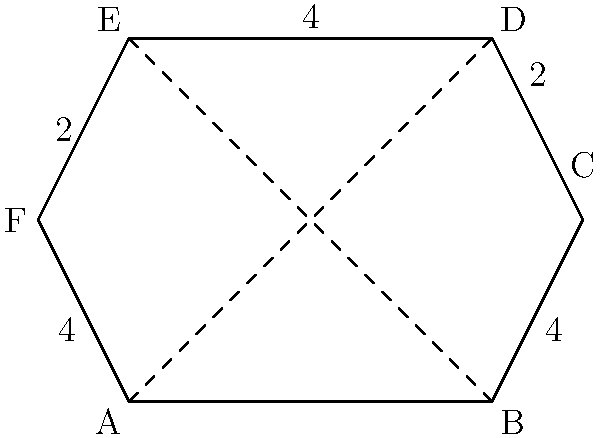In a study on the visual representation of medication in popular media, you encounter a hexagonal pill shape. The shape has alternating side lengths of 4 units and 2 units, as shown in the diagram. Calculate the area of this hexagonal pill shape to determine its visual impact on screen. To calculate the area of this irregular hexagon, we can divide it into six equilateral triangles and two rectangles:

1. First, let's calculate the area of one equilateral triangle:
   - The side length is 2 units
   - Area of equilateral triangle = $\frac{\sqrt{3}}{4} a^2$, where $a$ is the side length
   - Area of one triangle = $\frac{\sqrt{3}}{4} \cdot 2^2 = \sqrt{3}$ square units

2. There are six such triangles, so their total area is:
   $6 \cdot \sqrt{3}$ square units

3. Now, let's calculate the area of the two rectangles:
   - Each rectangle has a width of 4 units and a height of 2 units
   - Area of one rectangle = $4 \cdot 2 = 8$ square units
   - Area of two rectangles = $2 \cdot 8 = 16$ square units

4. The total area is the sum of the triangles and rectangles:
   Total Area = $(6 \cdot \sqrt{3}) + 16$ square units

5. Simplifying:
   Total Area = $6\sqrt{3} + 16$ square units

This formula gives the exact area. If a decimal approximation is needed:
$6\sqrt{3} + 16 \approx 26.39$ square units
Answer: $6\sqrt{3} + 16$ square units 